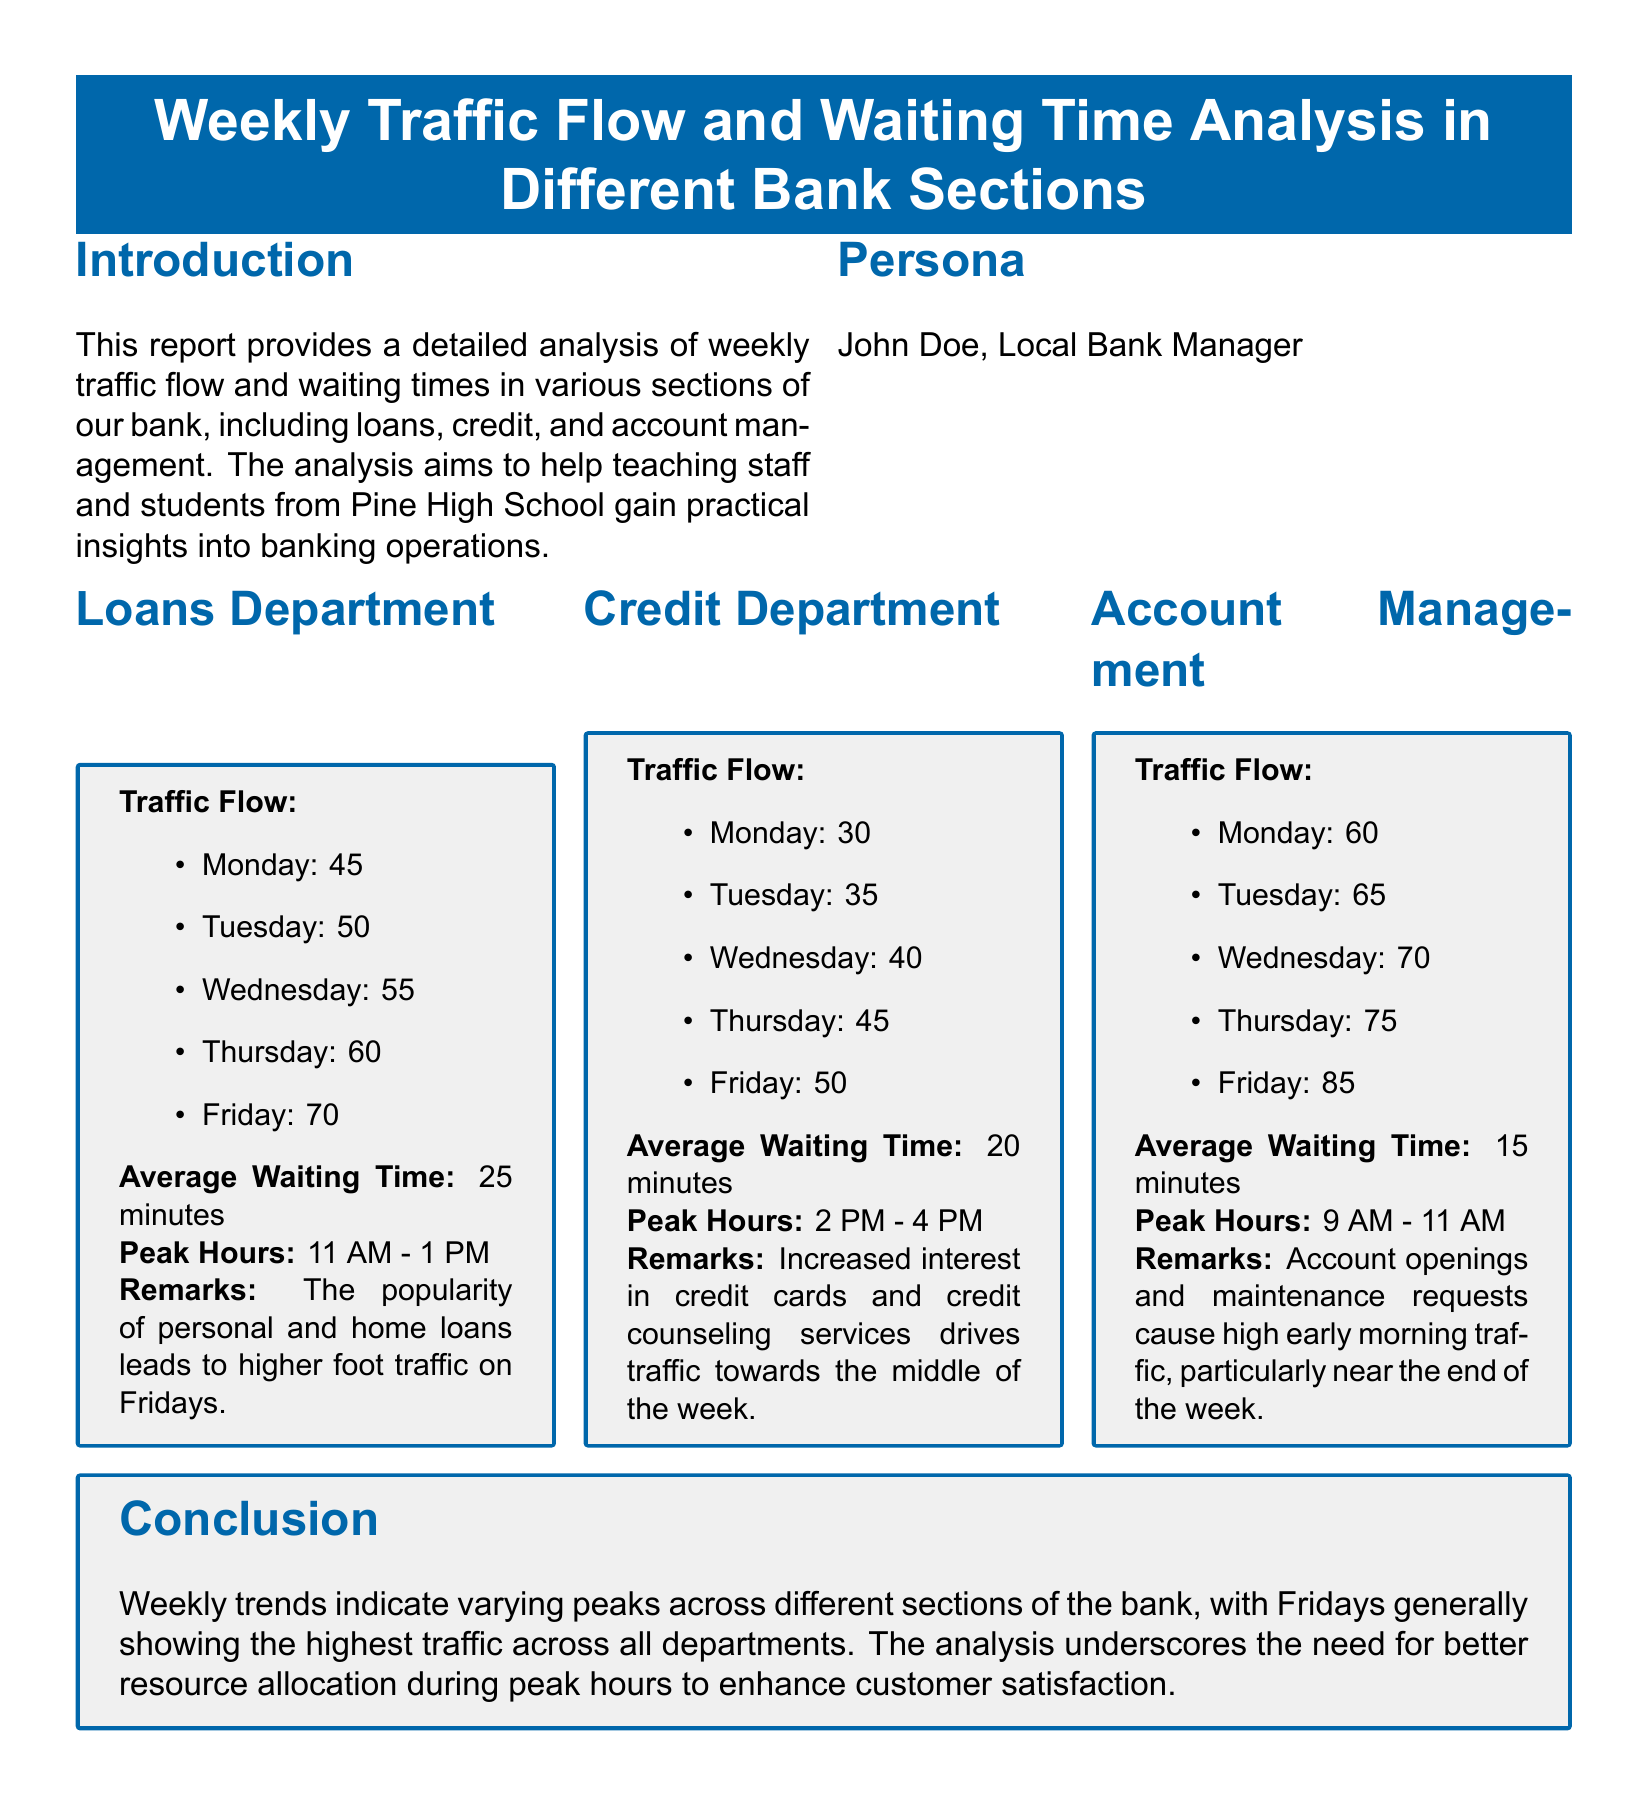What is the average waiting time in the Loans Department? The average waiting time in the Loans Department is provided in the analysis, which states it is 25 minutes.
Answer: 25 minutes What are the peak hours for the Account Management section? The peak hours for the Account Management section are mentioned as 9 AM - 11 AM.
Answer: 9 AM - 11 AM How many visitors were recorded in the Credit Department on Wednesday? The document lists the traffic flow for each day, showing that Wednesday had 40 visitors in the Credit Department.
Answer: 40 Which department has the highest average waiting time? By comparing the average waiting times from each department, it shows that Loans Department has the highest average waiting time of 25 minutes.
Answer: Loans Department What is the traffic flow on Friday in the Loans Department? The report specifies that the traffic flow in the Loans Department on Friday is 70 visitors.
Answer: 70 Which department experiences the highest traffic flow on Fridays? By analyzing the traffic flow data for Friday, it reveals that the Account Management section has the highest flow at 85 visitors.
Answer: Account Management What is noted as a reason for the increased traffic in the Credit Department midweek? The remarks in the Credit Department section indicate that increased interest in credit cards and credit counseling drives traffic midweek.
Answer: Credit cards and credit counseling What is the trend for account openings in the Account Management section? The report indicates a high early morning traffic trend particularly near the end of the week due to account openings.
Answer: High early morning traffic What conclusion is drawn about traffic patterns across the bank? The conclusion states that Fridays generally show the highest traffic across all departments.
Answer: Highest traffic on Fridays 